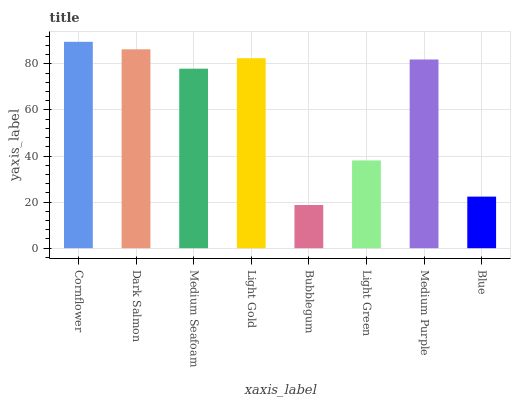Is Bubblegum the minimum?
Answer yes or no. Yes. Is Cornflower the maximum?
Answer yes or no. Yes. Is Dark Salmon the minimum?
Answer yes or no. No. Is Dark Salmon the maximum?
Answer yes or no. No. Is Cornflower greater than Dark Salmon?
Answer yes or no. Yes. Is Dark Salmon less than Cornflower?
Answer yes or no. Yes. Is Dark Salmon greater than Cornflower?
Answer yes or no. No. Is Cornflower less than Dark Salmon?
Answer yes or no. No. Is Medium Purple the high median?
Answer yes or no. Yes. Is Medium Seafoam the low median?
Answer yes or no. Yes. Is Light Gold the high median?
Answer yes or no. No. Is Light Green the low median?
Answer yes or no. No. 